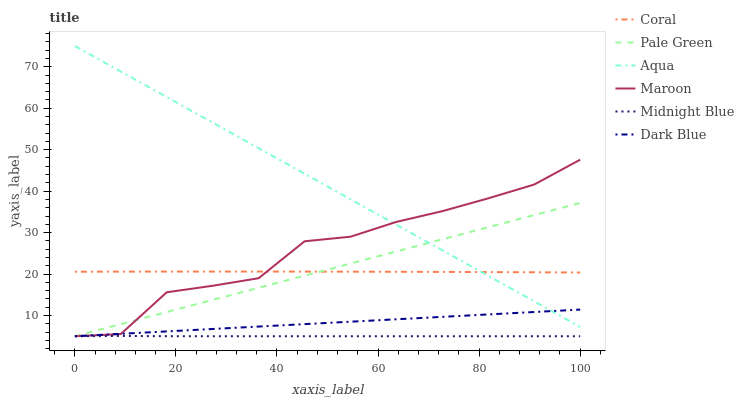Does Midnight Blue have the minimum area under the curve?
Answer yes or no. Yes. Does Aqua have the maximum area under the curve?
Answer yes or no. Yes. Does Coral have the minimum area under the curve?
Answer yes or no. No. Does Coral have the maximum area under the curve?
Answer yes or no. No. Is Dark Blue the smoothest?
Answer yes or no. Yes. Is Maroon the roughest?
Answer yes or no. Yes. Is Coral the smoothest?
Answer yes or no. No. Is Coral the roughest?
Answer yes or no. No. Does Midnight Blue have the lowest value?
Answer yes or no. Yes. Does Aqua have the lowest value?
Answer yes or no. No. Does Aqua have the highest value?
Answer yes or no. Yes. Does Coral have the highest value?
Answer yes or no. No. Is Midnight Blue less than Coral?
Answer yes or no. Yes. Is Aqua greater than Midnight Blue?
Answer yes or no. Yes. Does Coral intersect Maroon?
Answer yes or no. Yes. Is Coral less than Maroon?
Answer yes or no. No. Is Coral greater than Maroon?
Answer yes or no. No. Does Midnight Blue intersect Coral?
Answer yes or no. No. 